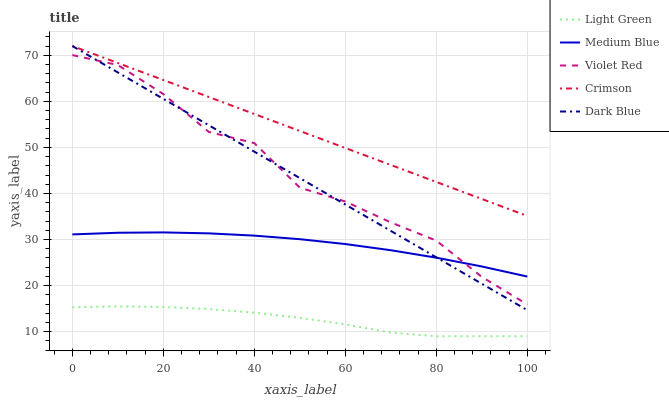Does Light Green have the minimum area under the curve?
Answer yes or no. Yes. Does Crimson have the maximum area under the curve?
Answer yes or no. Yes. Does Dark Blue have the minimum area under the curve?
Answer yes or no. No. Does Dark Blue have the maximum area under the curve?
Answer yes or no. No. Is Dark Blue the smoothest?
Answer yes or no. Yes. Is Violet Red the roughest?
Answer yes or no. Yes. Is Violet Red the smoothest?
Answer yes or no. No. Is Dark Blue the roughest?
Answer yes or no. No. Does Light Green have the lowest value?
Answer yes or no. Yes. Does Dark Blue have the lowest value?
Answer yes or no. No. Does Dark Blue have the highest value?
Answer yes or no. Yes. Does Violet Red have the highest value?
Answer yes or no. No. Is Light Green less than Violet Red?
Answer yes or no. Yes. Is Crimson greater than Violet Red?
Answer yes or no. Yes. Does Medium Blue intersect Violet Red?
Answer yes or no. Yes. Is Medium Blue less than Violet Red?
Answer yes or no. No. Is Medium Blue greater than Violet Red?
Answer yes or no. No. Does Light Green intersect Violet Red?
Answer yes or no. No. 